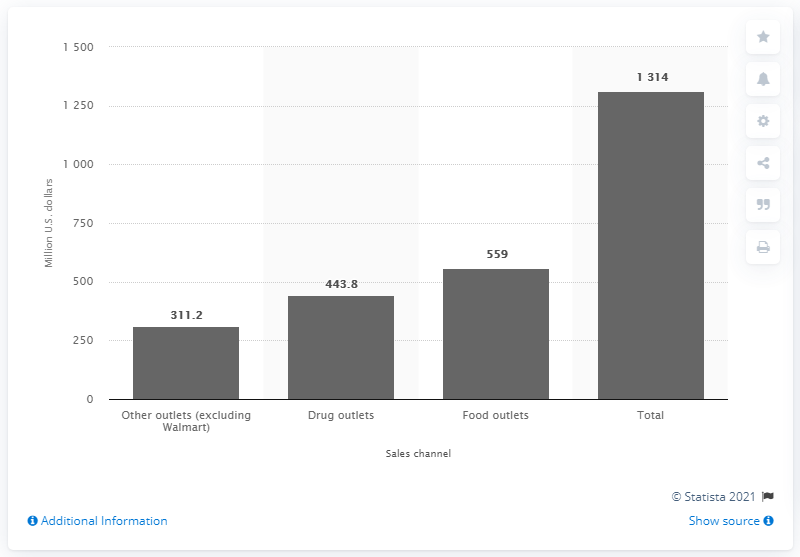How many U.S. dollars were spent on deodorant via food outlets in 2011/2012? In the year range 2011/2012, food outlets in the United States recorded deodorant sales amounting to approximately $559 million, as seen in the provided bar graph. 